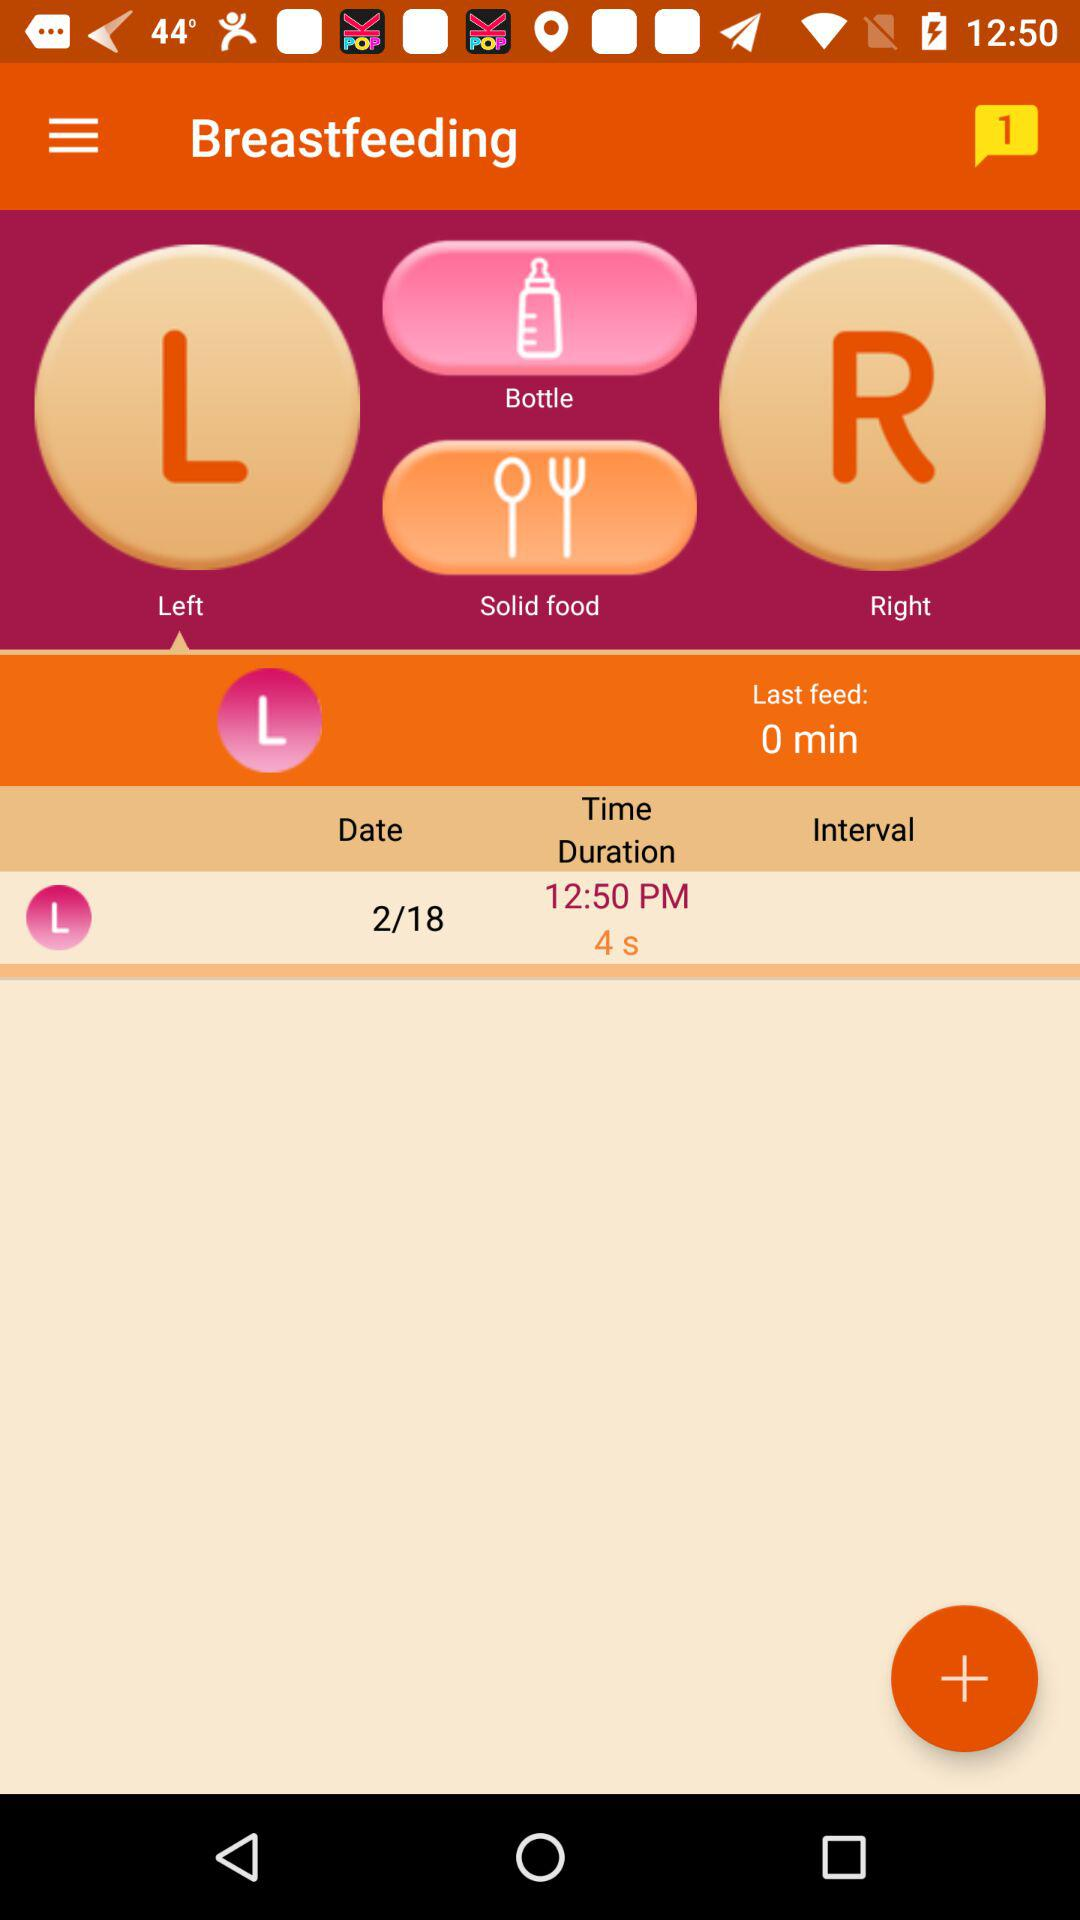On what date is left breastfeeding performed? Left breastfeeding is performed on 2/18. 